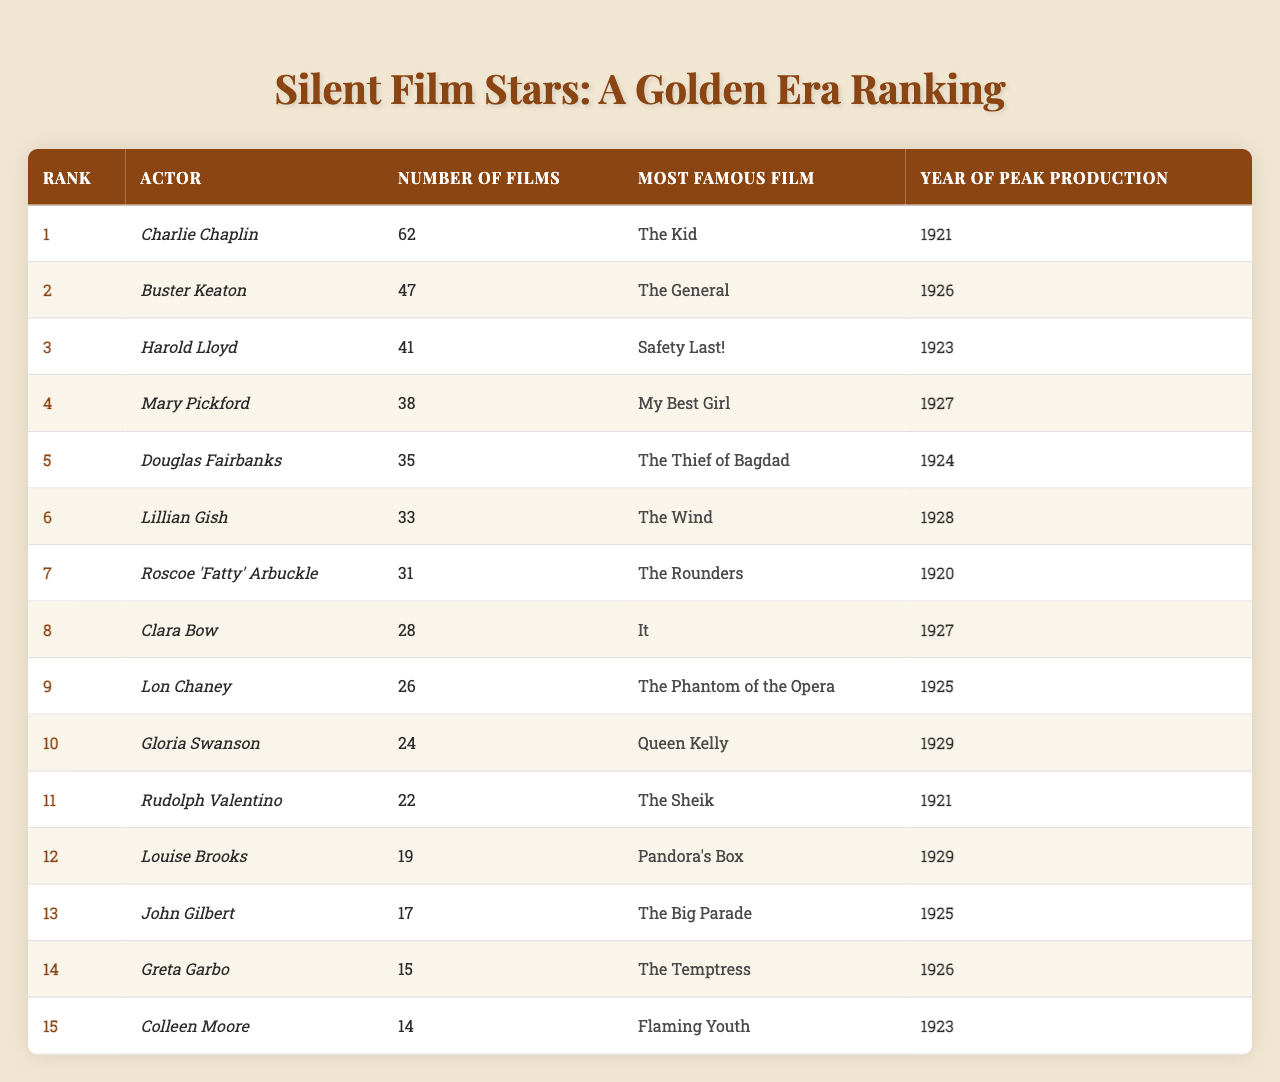What is the rank of Buster Keaton? Buster Keaton is listed in the table, and his rank is specified in the first column as 2.
Answer: 2 Which actor produced the most films during this period? By looking at the "Number of Films" column, Charlie Chaplin has the highest number at 62, making him the top-ranked actor.
Answer: Charlie Chaplin How many films did Mary Pickford produce? The table shows Mary Pickford is listed in the second column, and her "Number of Films" in the third column is 38.
Answer: 38 Which actor is associated with the film "The General"? The table indicates that Buster Keaton is associated with the film "The General" as his most famous film listed in the fourth column.
Answer: Buster Keaton Is Clara Bow ranked higher than Lon Chaney? Clara Bow is ranked 8th while Lon Chaney is 9th, thus Clara Bow is ranked higher than Lon Chaney.
Answer: Yes What is the total number of films produced by the top three actors? Adding the number of films from the top three actors: Charlie Chaplin (62) + Buster Keaton (47) + Harold Lloyd (41) gives us 62 + 47 + 41 = 150.
Answer: 150 What is the median number of films produced by the actors in this table? To find the median, we first list the number of films in order: [14, 15, 17, 19, 22, 24, 26, 28, 31, 33, 35, 38, 41, 47, 62]. There are 15 data points. The median is the 8th value, which is 28.
Answer: 28 Which year saw the peak production for Lillian Gish? The table specifies that Lillian Gish had her peak production year as 1928, which is listed in the last column next to her name.
Answer: 1928 How many more films did Charlie Chaplin produce than Douglas Fairbanks? Charlie Chaplin produced 62 films and Douglas Fairbanks produced 35 films. The difference is 62 - 35 = 27.
Answer: 27 Are any actors in this table associated with films made in 1929? The table shows that Gloria Swanson and Louise Brooks had their famous films released in 1929, confirming that there are actors associated with that year.
Answer: Yes 